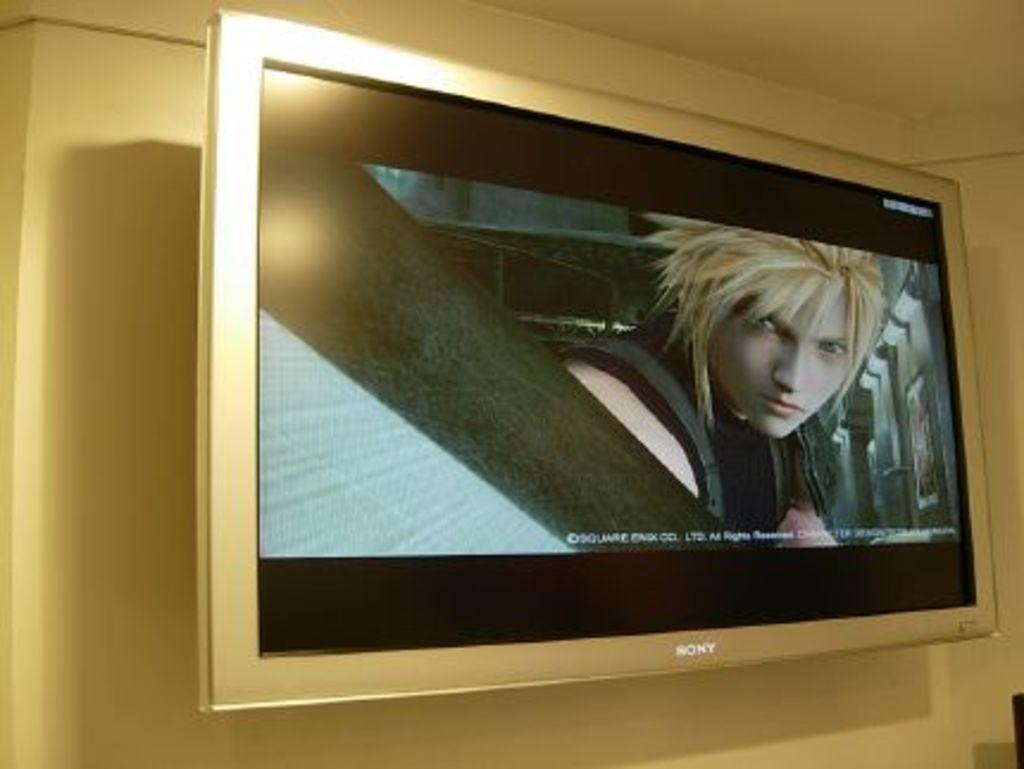Describe this image in one or two sentences. In this picture there is a Sony television which is attached to the wall is displaying a picture on it. 